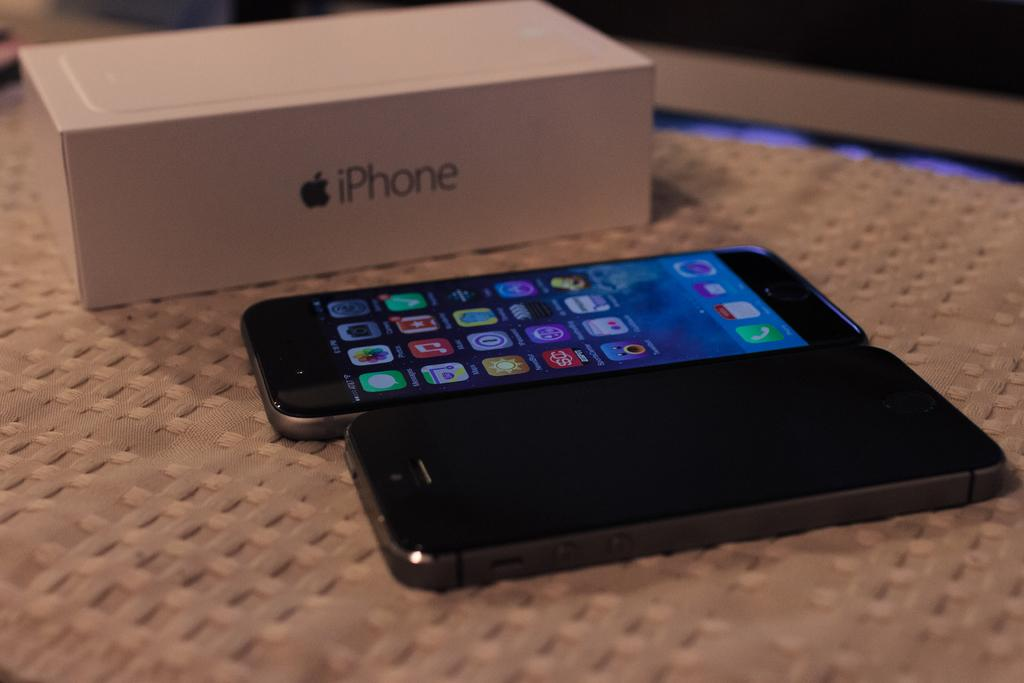<image>
Summarize the visual content of the image. 2 black cell phones laying outside of a cardboard iPhone box. 